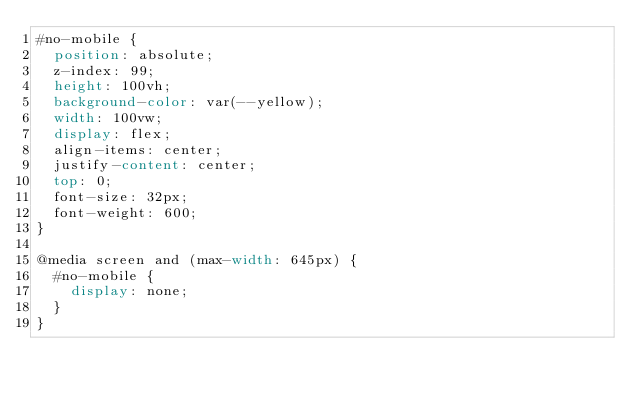<code> <loc_0><loc_0><loc_500><loc_500><_CSS_>#no-mobile {
  position: absolute;
  z-index: 99;
  height: 100vh;
  background-color: var(--yellow);
  width: 100vw;
  display: flex;
  align-items: center;
  justify-content: center;
  top: 0;
  font-size: 32px;
  font-weight: 600;
}

@media screen and (max-width: 645px) {
  #no-mobile {
    display: none;
  }
}
</code> 